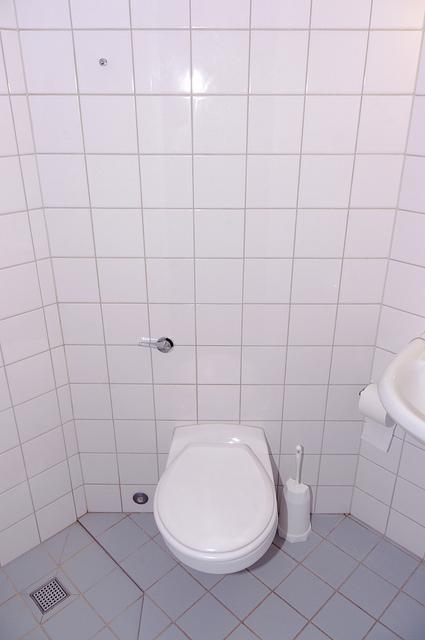How many rolls of toilet paper are there?
Give a very brief answer. 1. 